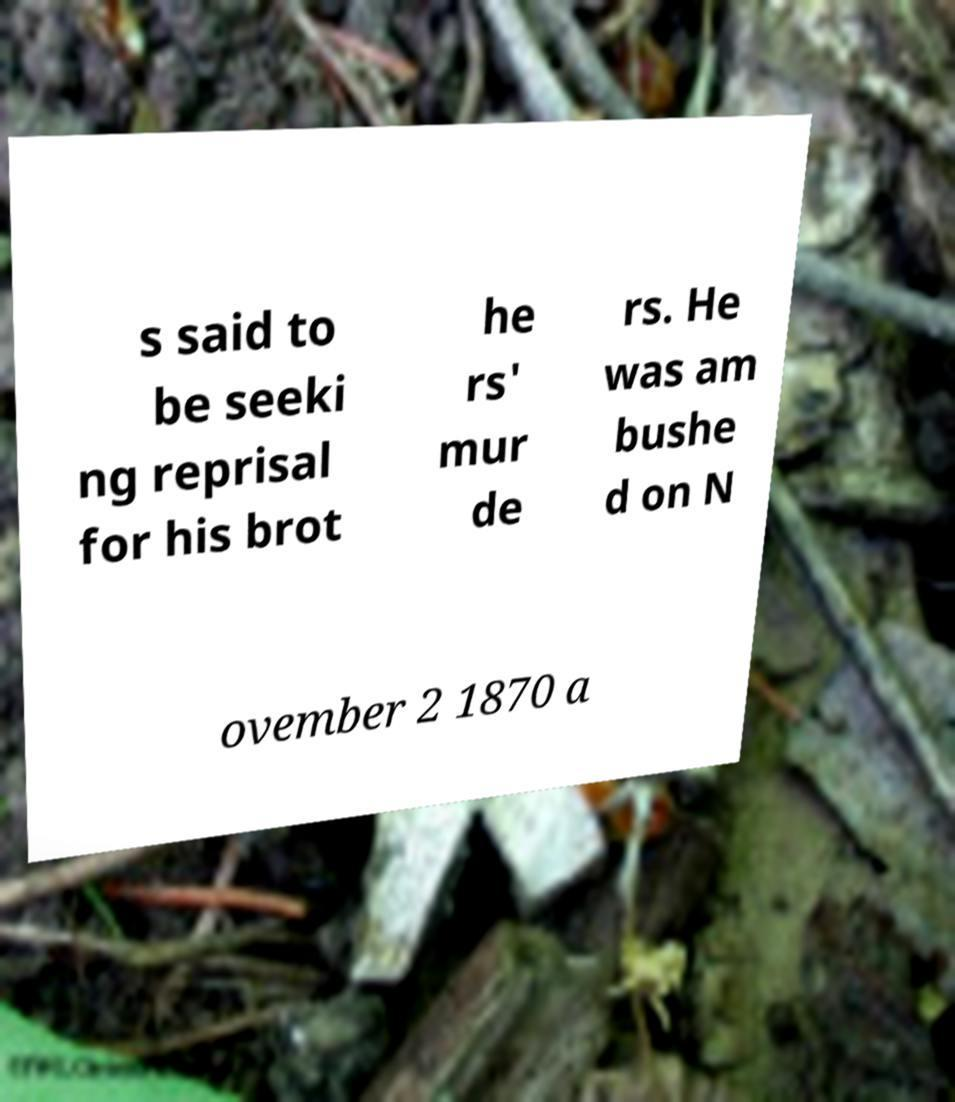There's text embedded in this image that I need extracted. Can you transcribe it verbatim? s said to be seeki ng reprisal for his brot he rs' mur de rs. He was am bushe d on N ovember 2 1870 a 